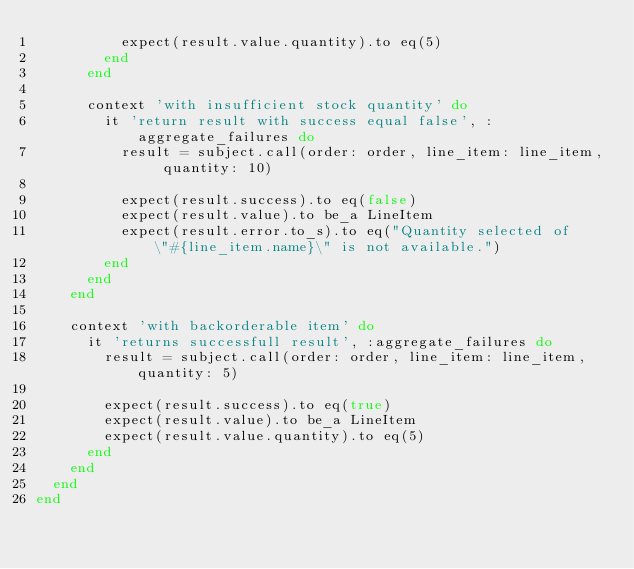<code> <loc_0><loc_0><loc_500><loc_500><_Ruby_>          expect(result.value.quantity).to eq(5)
        end
      end

      context 'with insufficient stock quantity' do
        it 'return result with success equal false', :aggregate_failures do
          result = subject.call(order: order, line_item: line_item, quantity: 10)

          expect(result.success).to eq(false)
          expect(result.value).to be_a LineItem
          expect(result.error.to_s).to eq("Quantity selected of \"#{line_item.name}\" is not available.")
        end
      end
    end

    context 'with backorderable item' do
      it 'returns successfull result', :aggregate_failures do
        result = subject.call(order: order, line_item: line_item, quantity: 5)

        expect(result.success).to eq(true)
        expect(result.value).to be_a LineItem
        expect(result.value.quantity).to eq(5)
      end
    end
  end
end
</code> 